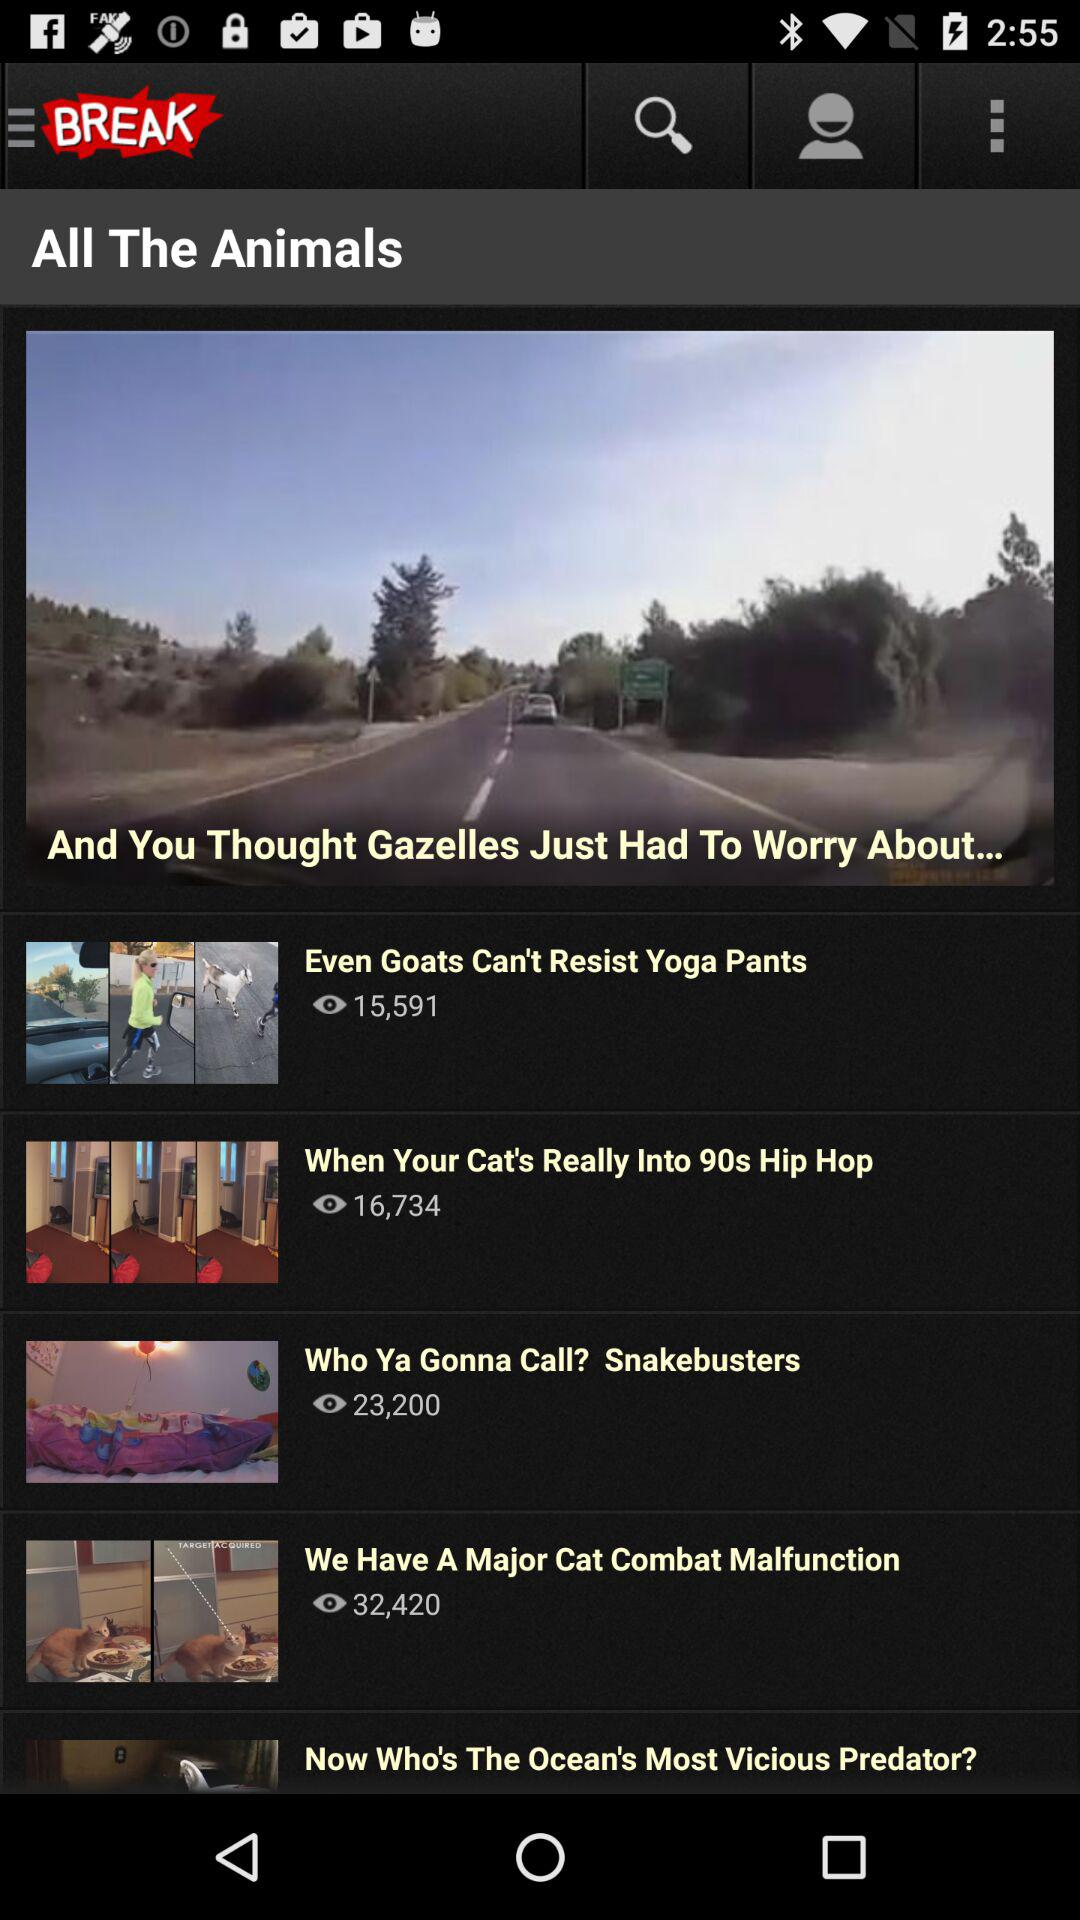How many views of the "Even Goats Can't Resist Yoga Pants" video are there? There are 15,591 views of the "Even Goats Can't Resist Yoga Pants" video. 